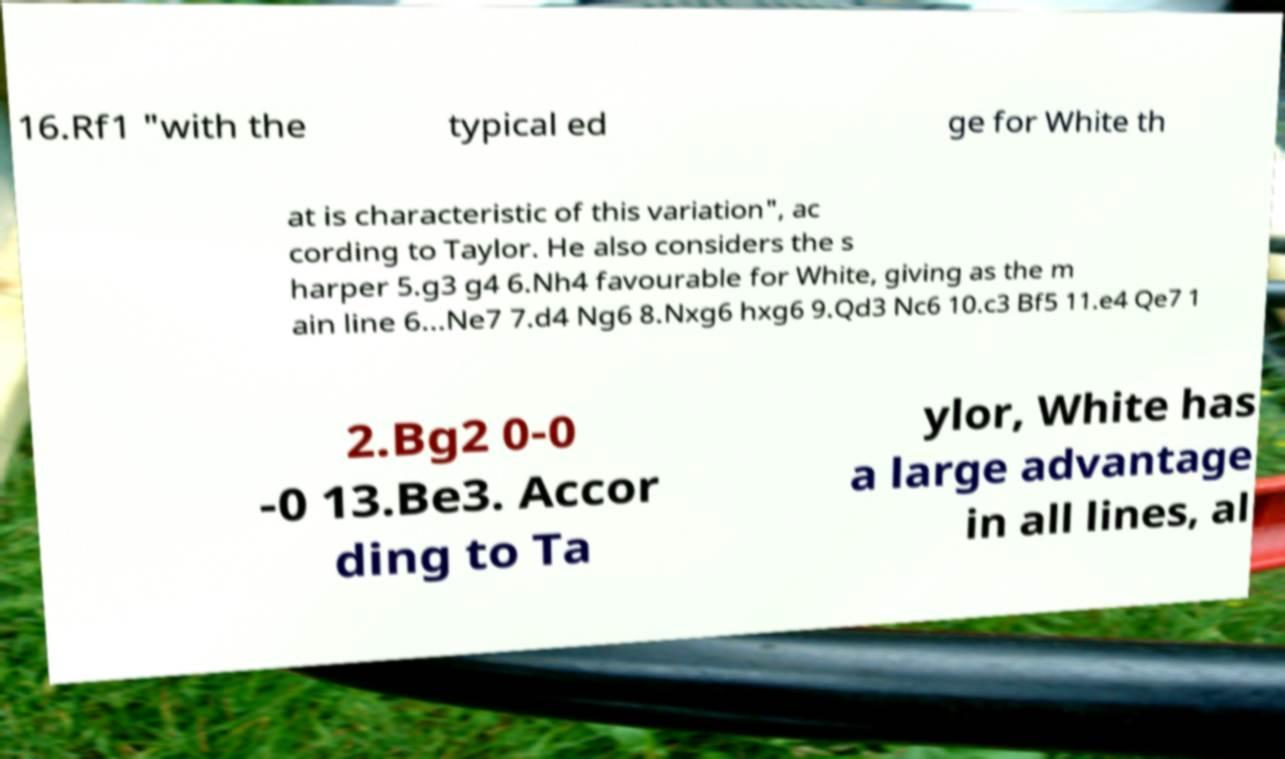Could you assist in decoding the text presented in this image and type it out clearly? 16.Rf1 "with the typical ed ge for White th at is characteristic of this variation", ac cording to Taylor. He also considers the s harper 5.g3 g4 6.Nh4 favourable for White, giving as the m ain line 6...Ne7 7.d4 Ng6 8.Nxg6 hxg6 9.Qd3 Nc6 10.c3 Bf5 11.e4 Qe7 1 2.Bg2 0-0 -0 13.Be3. Accor ding to Ta ylor, White has a large advantage in all lines, al 